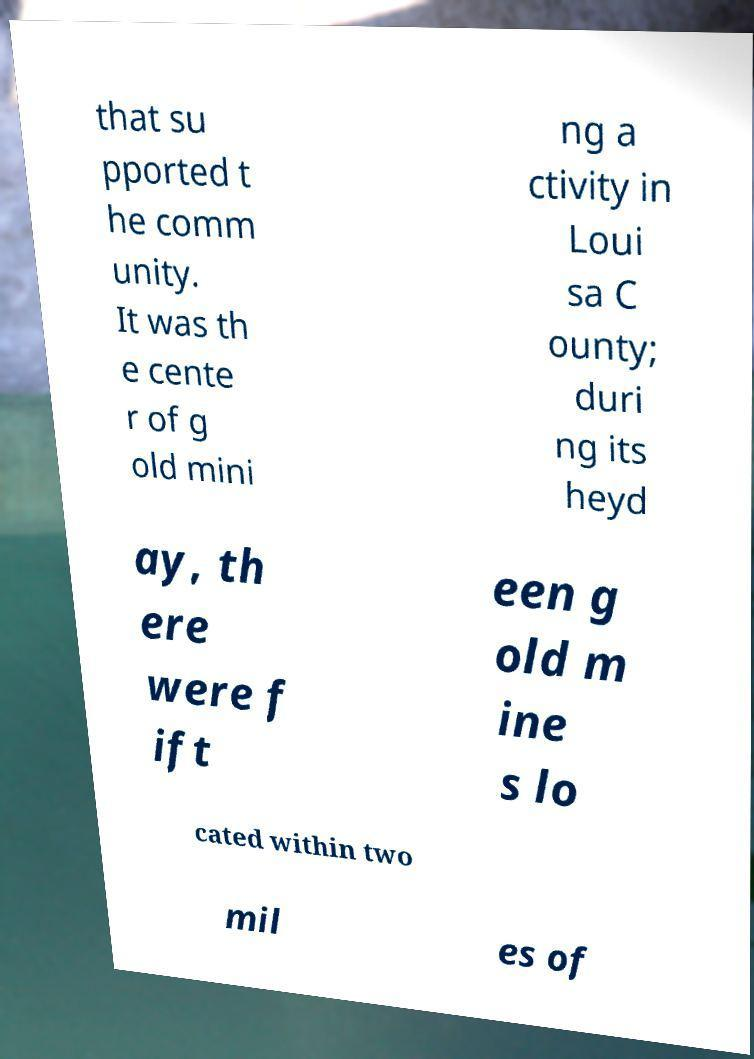I need the written content from this picture converted into text. Can you do that? that su pported t he comm unity. It was th e cente r of g old mini ng a ctivity in Loui sa C ounty; duri ng its heyd ay, th ere were f ift een g old m ine s lo cated within two mil es of 